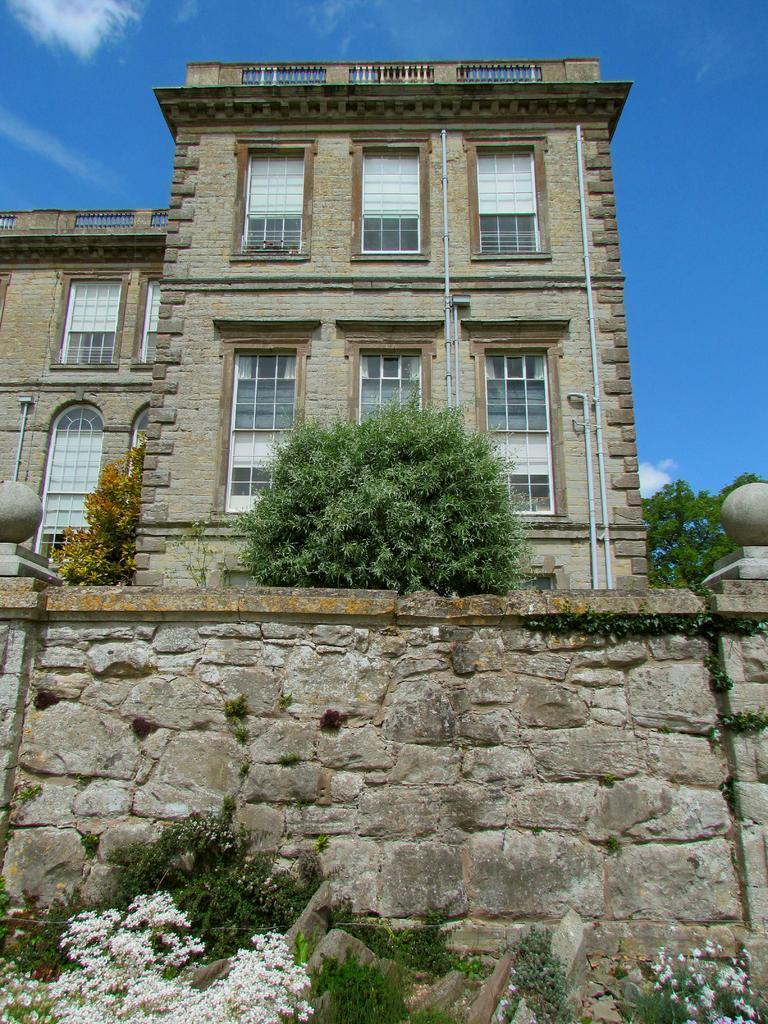Please provide a concise description of this image. In this image we can see there is a building, in front of the building there are some trees and plants. In the background there is a sky. 